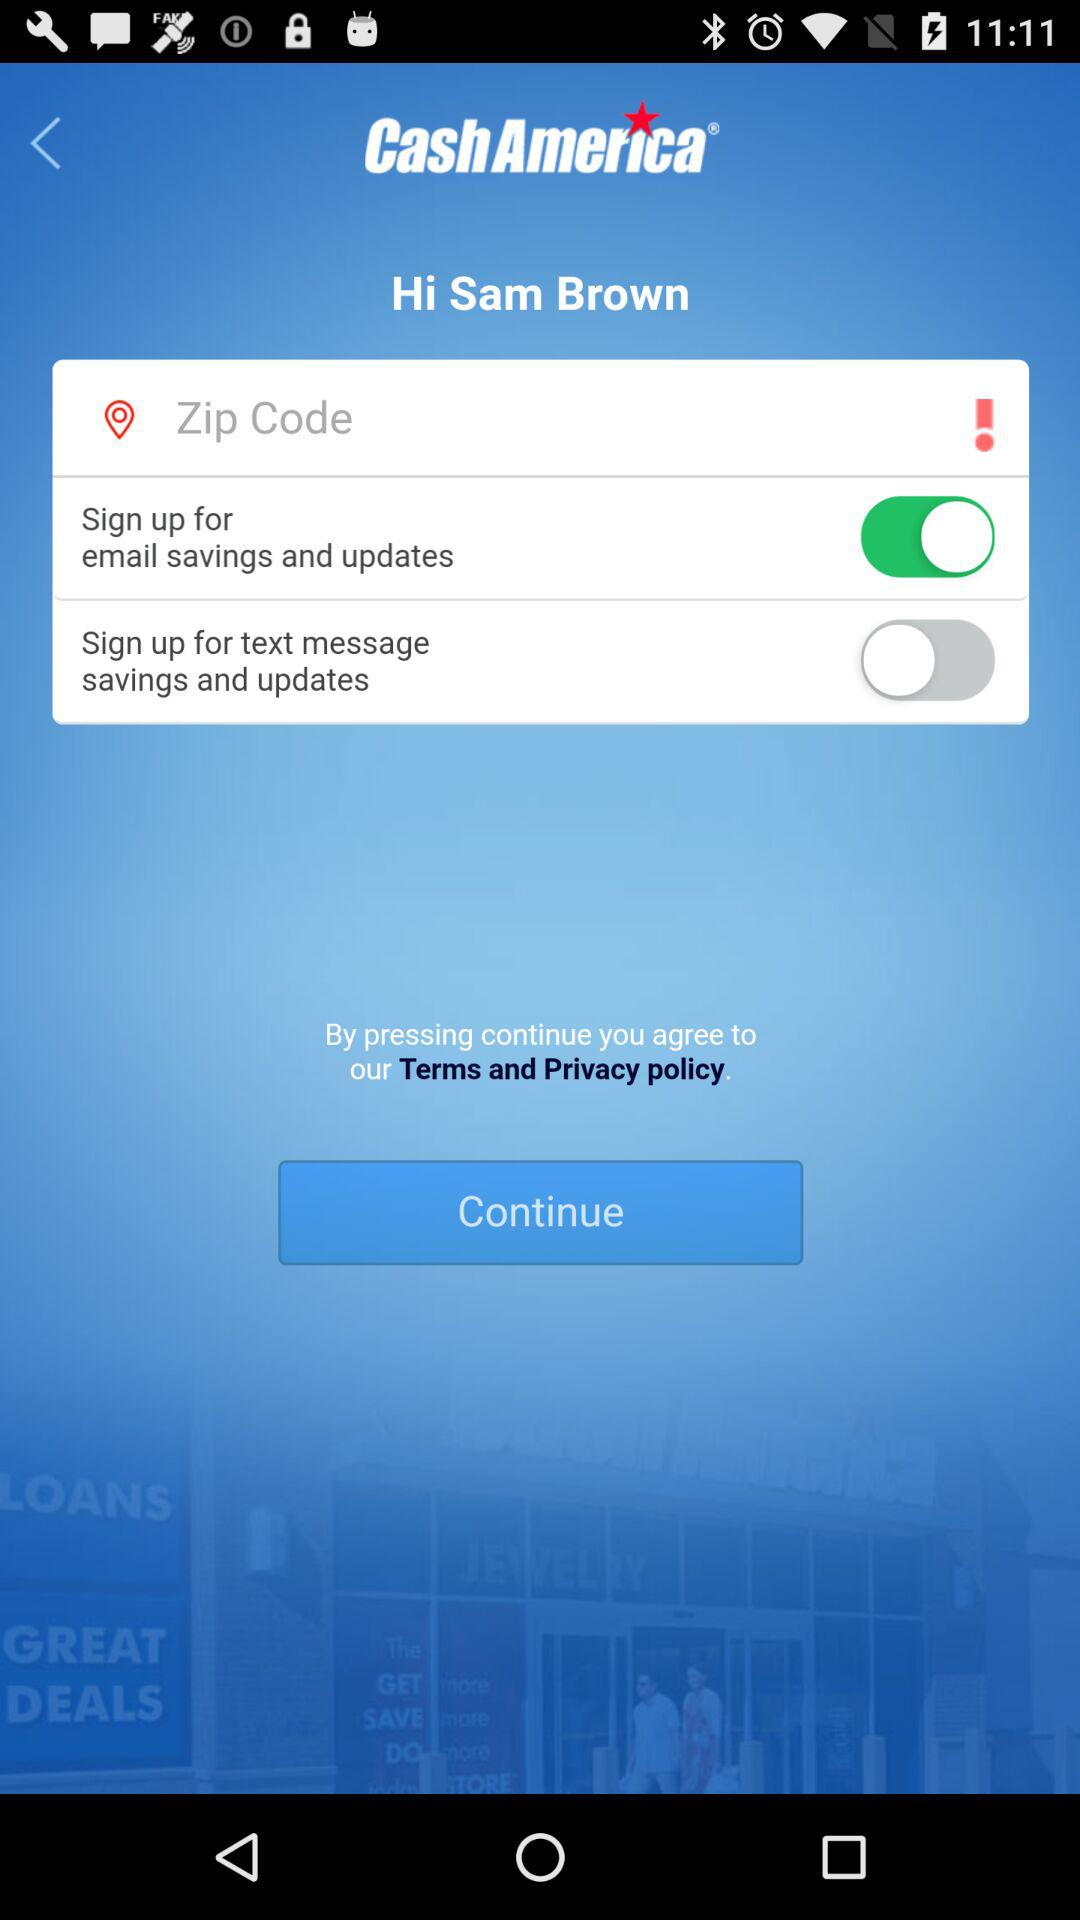What is the zip code?
When the provided information is insufficient, respond with <no answer>. <no answer> 